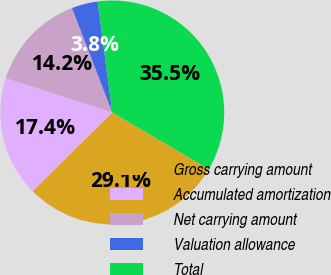Convert chart. <chart><loc_0><loc_0><loc_500><loc_500><pie_chart><fcel>Gross carrying amount<fcel>Accumulated amortization<fcel>Net carrying amount<fcel>Valuation allowance<fcel>Total<nl><fcel>29.15%<fcel>17.36%<fcel>14.18%<fcel>3.77%<fcel>35.54%<nl></chart> 